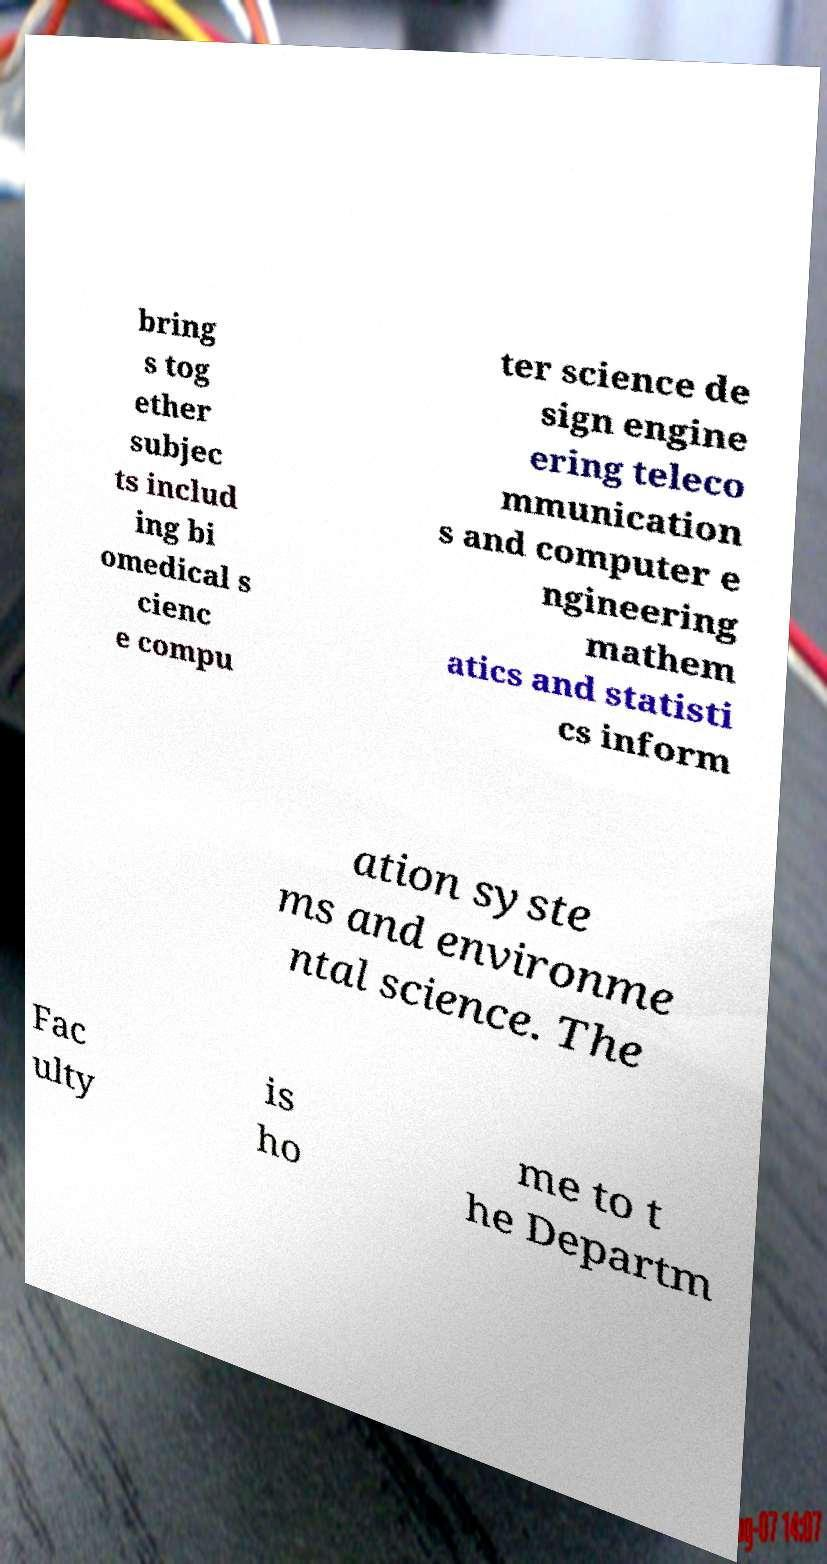What messages or text are displayed in this image? I need them in a readable, typed format. bring s tog ether subjec ts includ ing bi omedical s cienc e compu ter science de sign engine ering teleco mmunication s and computer e ngineering mathem atics and statisti cs inform ation syste ms and environme ntal science. The Fac ulty is ho me to t he Departm 